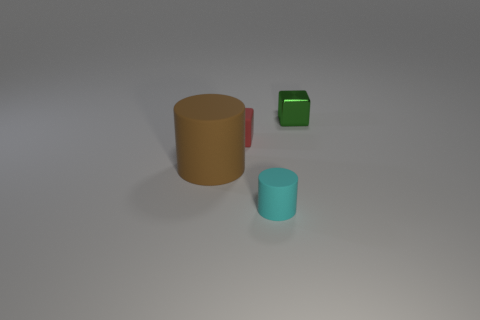Add 4 blocks. How many objects exist? 8 Subtract all green cubes. Subtract all cyan cylinders. How many cubes are left? 1 Subtract all red balls. How many yellow cylinders are left? 0 Subtract all small metal objects. Subtract all cylinders. How many objects are left? 1 Add 1 tiny metallic blocks. How many tiny metallic blocks are left? 2 Add 1 metal things. How many metal things exist? 2 Subtract 0 brown blocks. How many objects are left? 4 Subtract 2 cubes. How many cubes are left? 0 